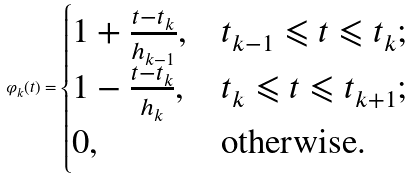Convert formula to latex. <formula><loc_0><loc_0><loc_500><loc_500>\varphi _ { k } ( t ) = \begin{cases} 1 + \frac { t - t _ { k } } { h _ { k - 1 } } , & t _ { k - 1 } \leqslant t \leqslant t _ { k } ; \\ 1 - \frac { t - t _ { k } } { h _ { k } } , & t _ { k } \leqslant t \leqslant t _ { k + 1 } ; \\ 0 , & \text {otherwise} . \end{cases}</formula> 